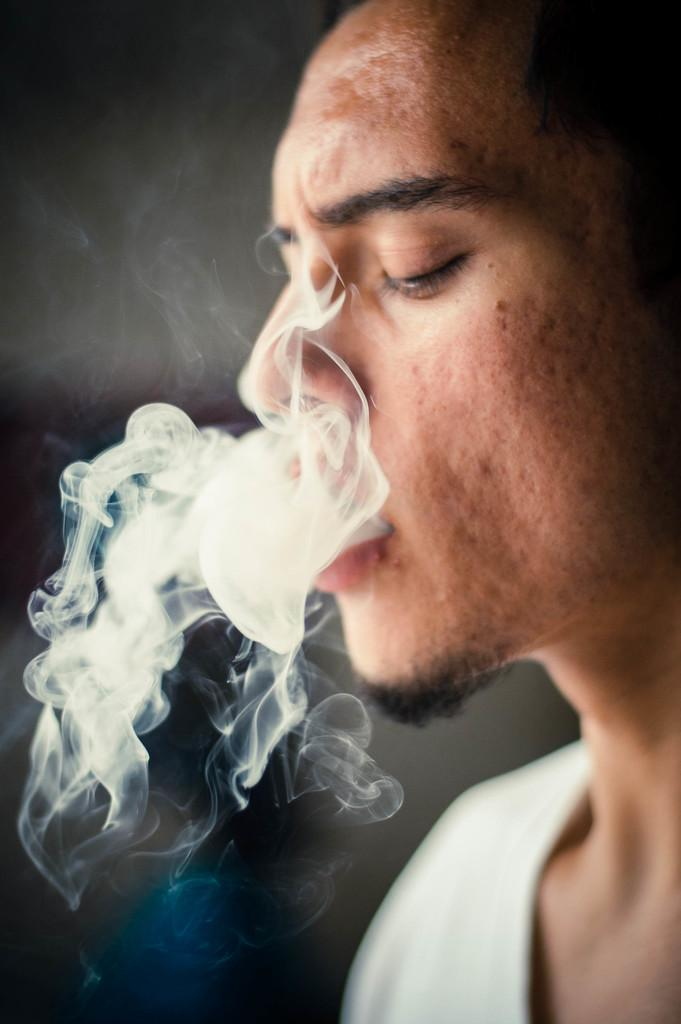Who or what is the main subject in the image? There is a person in the image. Can you describe the background of the image? The background of the image is blurred. What is the person in the image doing? The person is exhaling smoke. What hobbies does the person in the image have? There is no information about the person's hobbies in the image. 